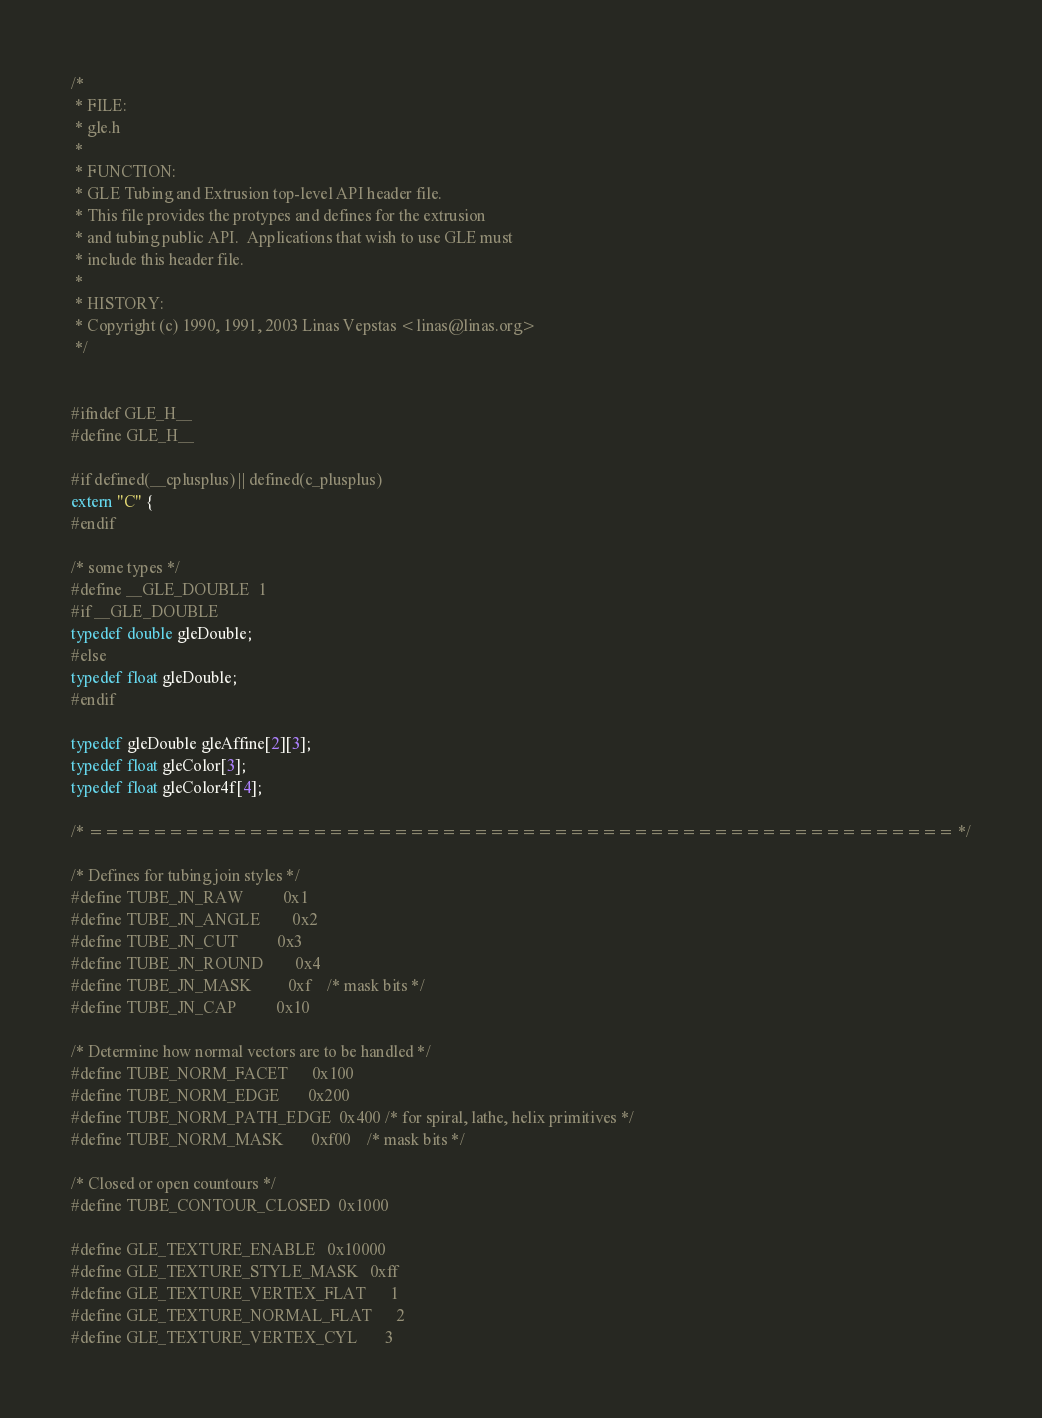Convert code to text. <code><loc_0><loc_0><loc_500><loc_500><_C_>
/*
 * FILE:
 * gle.h
 *
 * FUNCTION:
 * GLE Tubing and Extrusion top-level API header file.
 * This file provides the protypes and defines for the extrusion 
 * and tubing public API.  Applications that wish to use GLE must
 * include this header file.
 *
 * HISTORY:
 * Copyright (c) 1990, 1991, 2003 Linas Vepstas <linas@linas.org>
 */


#ifndef GLE_H__
#define GLE_H__

#if defined(__cplusplus) || defined(c_plusplus)
extern "C" {
#endif

/* some types */
#define __GLE_DOUBLE  1
#if __GLE_DOUBLE
typedef double gleDouble;
#else 
typedef float gleDouble;
#endif

typedef gleDouble gleAffine[2][3];
typedef float gleColor[3];
typedef float gleColor4f[4];

/* ====================================================== */

/* Defines for tubing join styles */
#define TUBE_JN_RAW          0x1
#define TUBE_JN_ANGLE        0x2
#define TUBE_JN_CUT          0x3
#define TUBE_JN_ROUND        0x4
#define TUBE_JN_MASK         0xf    /* mask bits */
#define TUBE_JN_CAP          0x10

/* Determine how normal vectors are to be handled */
#define TUBE_NORM_FACET      0x100
#define TUBE_NORM_EDGE       0x200
#define TUBE_NORM_PATH_EDGE  0x400 /* for spiral, lathe, helix primitives */
#define TUBE_NORM_MASK       0xf00    /* mask bits */

/* Closed or open countours */
#define TUBE_CONTOUR_CLOSED	0x1000

#define GLE_TEXTURE_ENABLE	0x10000
#define GLE_TEXTURE_STYLE_MASK	0xff
#define GLE_TEXTURE_VERTEX_FLAT		1
#define GLE_TEXTURE_NORMAL_FLAT		2
#define GLE_TEXTURE_VERTEX_CYL		3</code> 